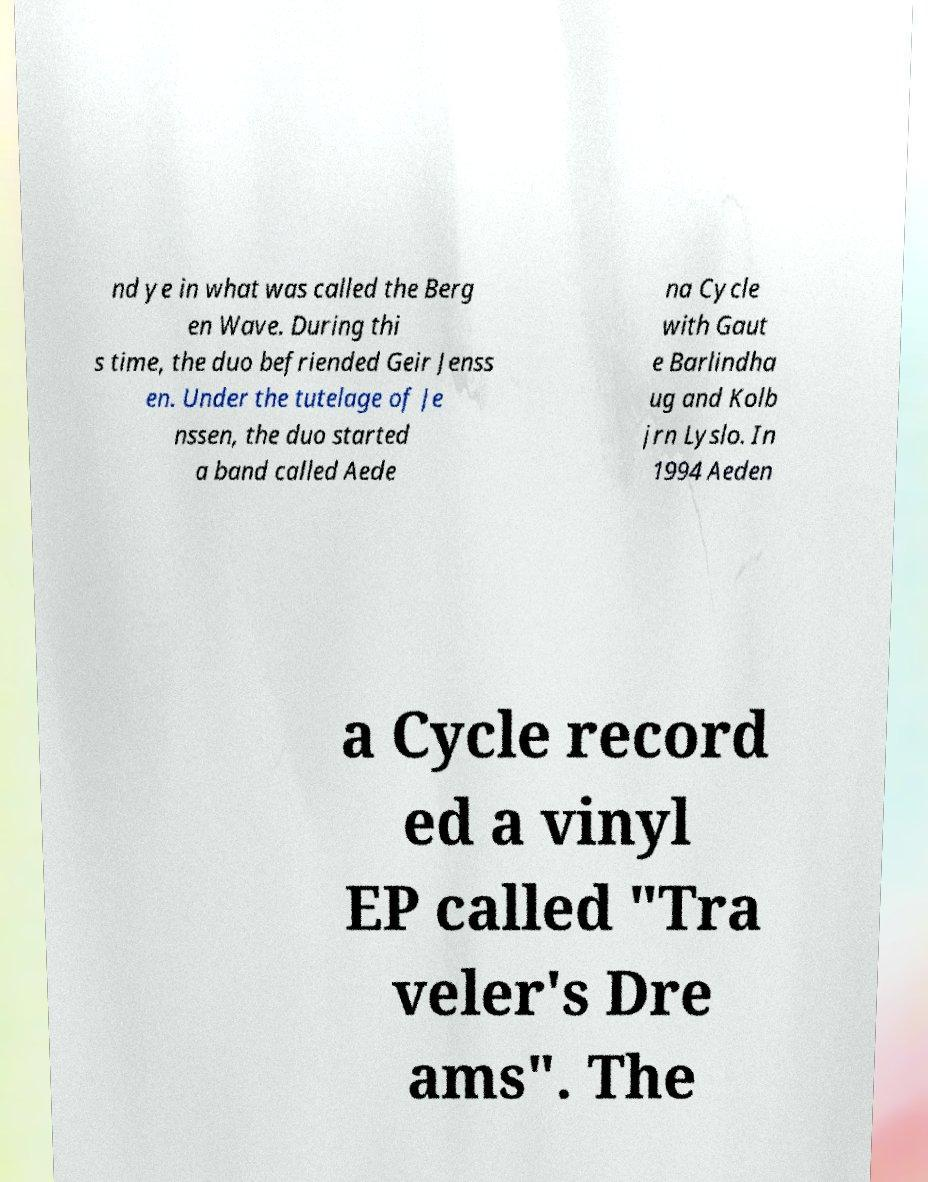I need the written content from this picture converted into text. Can you do that? nd ye in what was called the Berg en Wave. During thi s time, the duo befriended Geir Jenss en. Under the tutelage of Je nssen, the duo started a band called Aede na Cycle with Gaut e Barlindha ug and Kolb jrn Lyslo. In 1994 Aeden a Cycle record ed a vinyl EP called "Tra veler's Dre ams". The 